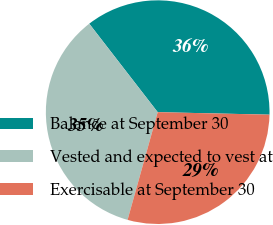Convert chart to OTSL. <chart><loc_0><loc_0><loc_500><loc_500><pie_chart><fcel>Balance at September 30<fcel>Vested and expected to vest at<fcel>Exercisable at September 30<nl><fcel>35.84%<fcel>35.18%<fcel>28.98%<nl></chart> 